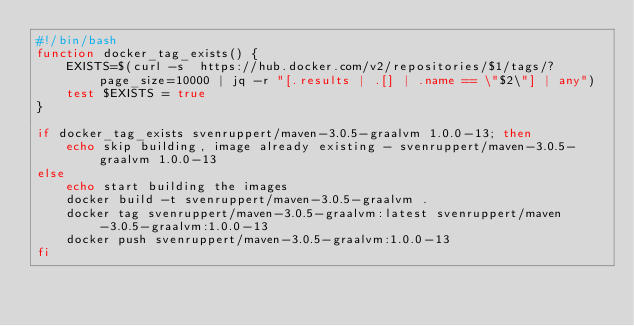<code> <loc_0><loc_0><loc_500><loc_500><_Bash_>#!/bin/bash
function docker_tag_exists() {
    EXISTS=$(curl -s  https://hub.docker.com/v2/repositories/$1/tags/?page_size=10000 | jq -r "[.results | .[] | .name == \"$2\"] | any")
    test $EXISTS = true
}

if docker_tag_exists svenruppert/maven-3.0.5-graalvm 1.0.0-13; then
    echo skip building, image already existing - svenruppert/maven-3.0.5-graalvm 1.0.0-13
else
    echo start building the images
    docker build -t svenruppert/maven-3.0.5-graalvm .
    docker tag svenruppert/maven-3.0.5-graalvm:latest svenruppert/maven-3.0.5-graalvm:1.0.0-13
    docker push svenruppert/maven-3.0.5-graalvm:1.0.0-13
fi</code> 